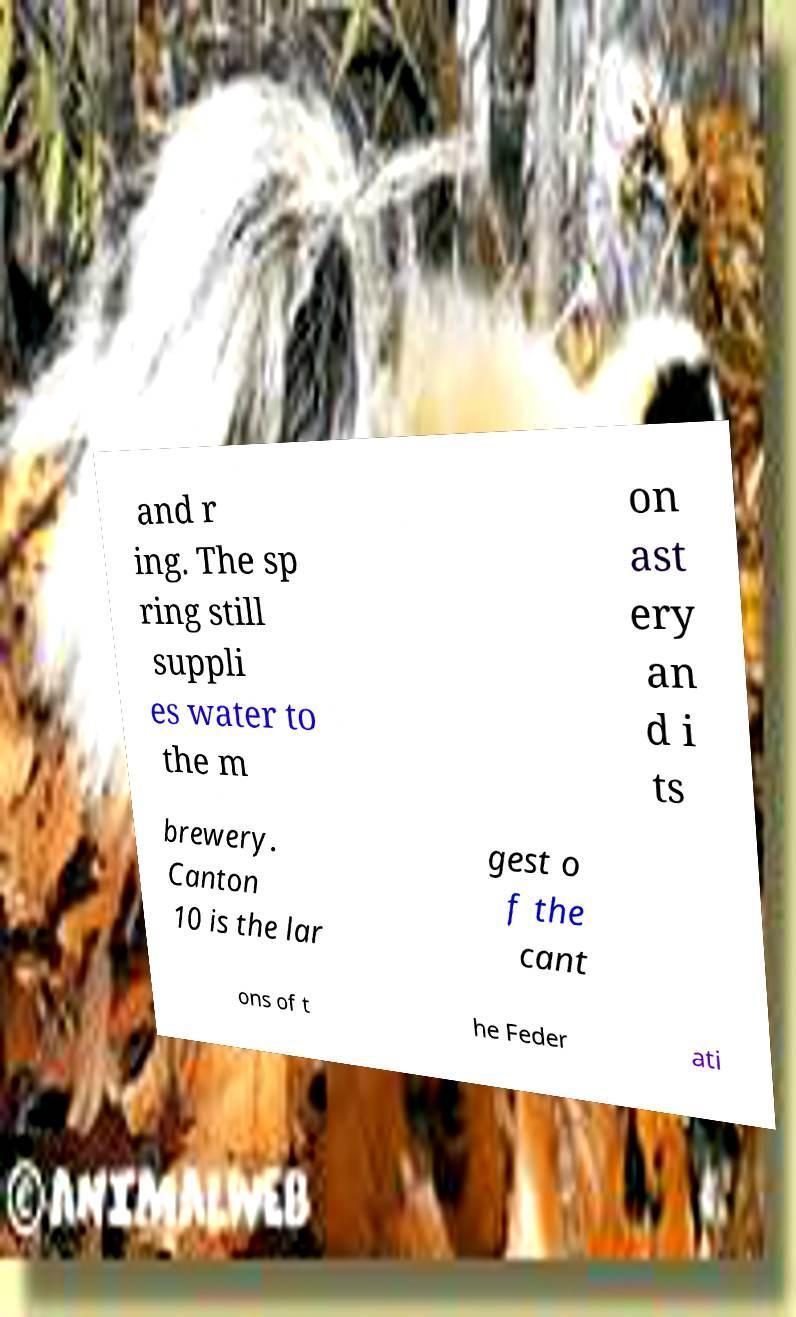Could you extract and type out the text from this image? and r ing. The sp ring still suppli es water to the m on ast ery an d i ts brewery. Canton 10 is the lar gest o f the cant ons of t he Feder ati 